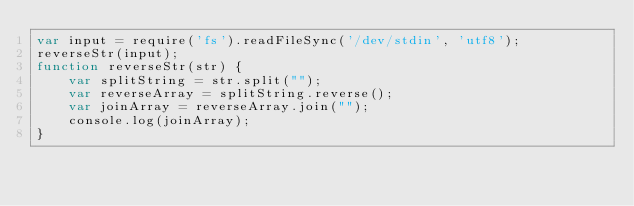Convert code to text. <code><loc_0><loc_0><loc_500><loc_500><_JavaScript_>var input = require('fs').readFileSync('/dev/stdin', 'utf8');
reverseStr(input);
function reverseStr(str) {
    var splitString = str.split("");  
    var reverseArray = splitString.reverse(); 
    var joinArray = reverseArray.join("");     
    console.log(joinArray);
}</code> 